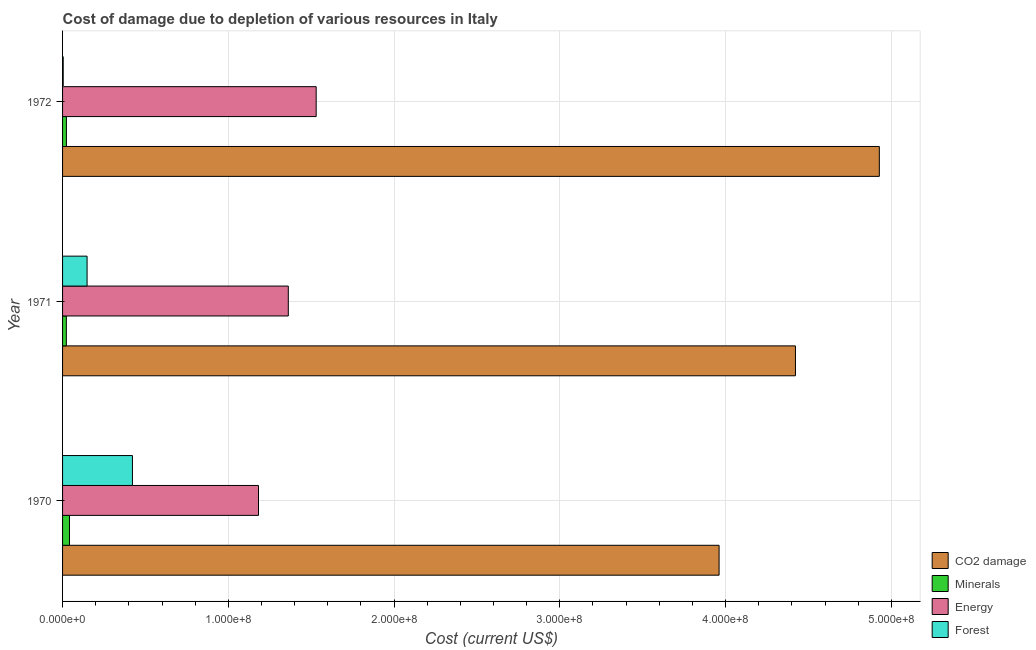How many different coloured bars are there?
Offer a terse response. 4. Are the number of bars per tick equal to the number of legend labels?
Your answer should be very brief. Yes. How many bars are there on the 3rd tick from the top?
Ensure brevity in your answer.  4. How many bars are there on the 2nd tick from the bottom?
Your answer should be very brief. 4. What is the label of the 2nd group of bars from the top?
Your answer should be compact. 1971. In how many cases, is the number of bars for a given year not equal to the number of legend labels?
Provide a short and direct response. 0. What is the cost of damage due to depletion of coal in 1971?
Provide a succinct answer. 4.42e+08. Across all years, what is the maximum cost of damage due to depletion of energy?
Make the answer very short. 1.53e+08. Across all years, what is the minimum cost of damage due to depletion of minerals?
Provide a succinct answer. 2.28e+06. In which year was the cost of damage due to depletion of coal minimum?
Ensure brevity in your answer.  1970. What is the total cost of damage due to depletion of energy in the graph?
Offer a very short reply. 4.07e+08. What is the difference between the cost of damage due to depletion of energy in 1970 and that in 1972?
Keep it short and to the point. -3.48e+07. What is the difference between the cost of damage due to depletion of energy in 1972 and the cost of damage due to depletion of minerals in 1971?
Your answer should be compact. 1.51e+08. What is the average cost of damage due to depletion of coal per year?
Keep it short and to the point. 4.44e+08. In the year 1971, what is the difference between the cost of damage due to depletion of forests and cost of damage due to depletion of coal?
Your response must be concise. -4.27e+08. Is the cost of damage due to depletion of coal in 1970 less than that in 1971?
Ensure brevity in your answer.  Yes. Is the difference between the cost of damage due to depletion of coal in 1970 and 1972 greater than the difference between the cost of damage due to depletion of energy in 1970 and 1972?
Give a very brief answer. No. What is the difference between the highest and the second highest cost of damage due to depletion of minerals?
Keep it short and to the point. 1.86e+06. What is the difference between the highest and the lowest cost of damage due to depletion of energy?
Offer a very short reply. 3.48e+07. In how many years, is the cost of damage due to depletion of coal greater than the average cost of damage due to depletion of coal taken over all years?
Offer a terse response. 1. Is the sum of the cost of damage due to depletion of forests in 1970 and 1971 greater than the maximum cost of damage due to depletion of coal across all years?
Offer a terse response. No. Is it the case that in every year, the sum of the cost of damage due to depletion of coal and cost of damage due to depletion of minerals is greater than the sum of cost of damage due to depletion of energy and cost of damage due to depletion of forests?
Your answer should be very brief. Yes. What does the 2nd bar from the top in 1970 represents?
Offer a terse response. Energy. What does the 2nd bar from the bottom in 1972 represents?
Keep it short and to the point. Minerals. Are all the bars in the graph horizontal?
Keep it short and to the point. Yes. How many years are there in the graph?
Your answer should be compact. 3. What is the difference between two consecutive major ticks on the X-axis?
Make the answer very short. 1.00e+08. Does the graph contain grids?
Give a very brief answer. Yes. Where does the legend appear in the graph?
Offer a very short reply. Bottom right. How are the legend labels stacked?
Your response must be concise. Vertical. What is the title of the graph?
Offer a very short reply. Cost of damage due to depletion of various resources in Italy . What is the label or title of the X-axis?
Your answer should be compact. Cost (current US$). What is the label or title of the Y-axis?
Provide a short and direct response. Year. What is the Cost (current US$) in CO2 damage in 1970?
Ensure brevity in your answer.  3.96e+08. What is the Cost (current US$) in Minerals in 1970?
Give a very brief answer. 4.17e+06. What is the Cost (current US$) in Energy in 1970?
Your response must be concise. 1.18e+08. What is the Cost (current US$) in Forest in 1970?
Your answer should be compact. 4.22e+07. What is the Cost (current US$) of CO2 damage in 1971?
Make the answer very short. 4.42e+08. What is the Cost (current US$) of Minerals in 1971?
Make the answer very short. 2.28e+06. What is the Cost (current US$) in Energy in 1971?
Provide a succinct answer. 1.36e+08. What is the Cost (current US$) in Forest in 1971?
Give a very brief answer. 1.48e+07. What is the Cost (current US$) of CO2 damage in 1972?
Provide a short and direct response. 4.93e+08. What is the Cost (current US$) in Minerals in 1972?
Give a very brief answer. 2.32e+06. What is the Cost (current US$) of Energy in 1972?
Ensure brevity in your answer.  1.53e+08. What is the Cost (current US$) of Forest in 1972?
Keep it short and to the point. 3.87e+05. Across all years, what is the maximum Cost (current US$) in CO2 damage?
Make the answer very short. 4.93e+08. Across all years, what is the maximum Cost (current US$) in Minerals?
Your response must be concise. 4.17e+06. Across all years, what is the maximum Cost (current US$) of Energy?
Provide a short and direct response. 1.53e+08. Across all years, what is the maximum Cost (current US$) of Forest?
Offer a very short reply. 4.22e+07. Across all years, what is the minimum Cost (current US$) in CO2 damage?
Make the answer very short. 3.96e+08. Across all years, what is the minimum Cost (current US$) of Minerals?
Your answer should be compact. 2.28e+06. Across all years, what is the minimum Cost (current US$) of Energy?
Make the answer very short. 1.18e+08. Across all years, what is the minimum Cost (current US$) in Forest?
Ensure brevity in your answer.  3.87e+05. What is the total Cost (current US$) of CO2 damage in the graph?
Offer a terse response. 1.33e+09. What is the total Cost (current US$) of Minerals in the graph?
Provide a succinct answer. 8.77e+06. What is the total Cost (current US$) in Energy in the graph?
Ensure brevity in your answer.  4.07e+08. What is the total Cost (current US$) in Forest in the graph?
Your response must be concise. 5.73e+07. What is the difference between the Cost (current US$) in CO2 damage in 1970 and that in 1971?
Your answer should be very brief. -4.61e+07. What is the difference between the Cost (current US$) in Minerals in 1970 and that in 1971?
Offer a terse response. 1.89e+06. What is the difference between the Cost (current US$) in Energy in 1970 and that in 1971?
Offer a very short reply. -1.80e+07. What is the difference between the Cost (current US$) in Forest in 1970 and that in 1971?
Ensure brevity in your answer.  2.74e+07. What is the difference between the Cost (current US$) in CO2 damage in 1970 and that in 1972?
Offer a very short reply. -9.67e+07. What is the difference between the Cost (current US$) of Minerals in 1970 and that in 1972?
Ensure brevity in your answer.  1.86e+06. What is the difference between the Cost (current US$) of Energy in 1970 and that in 1972?
Keep it short and to the point. -3.48e+07. What is the difference between the Cost (current US$) in Forest in 1970 and that in 1972?
Provide a succinct answer. 4.18e+07. What is the difference between the Cost (current US$) of CO2 damage in 1971 and that in 1972?
Offer a terse response. -5.06e+07. What is the difference between the Cost (current US$) of Minerals in 1971 and that in 1972?
Your answer should be compact. -3.72e+04. What is the difference between the Cost (current US$) in Energy in 1971 and that in 1972?
Keep it short and to the point. -1.68e+07. What is the difference between the Cost (current US$) of Forest in 1971 and that in 1972?
Ensure brevity in your answer.  1.44e+07. What is the difference between the Cost (current US$) of CO2 damage in 1970 and the Cost (current US$) of Minerals in 1971?
Provide a short and direct response. 3.94e+08. What is the difference between the Cost (current US$) of CO2 damage in 1970 and the Cost (current US$) of Energy in 1971?
Your answer should be compact. 2.60e+08. What is the difference between the Cost (current US$) in CO2 damage in 1970 and the Cost (current US$) in Forest in 1971?
Keep it short and to the point. 3.81e+08. What is the difference between the Cost (current US$) in Minerals in 1970 and the Cost (current US$) in Energy in 1971?
Give a very brief answer. -1.32e+08. What is the difference between the Cost (current US$) in Minerals in 1970 and the Cost (current US$) in Forest in 1971?
Keep it short and to the point. -1.06e+07. What is the difference between the Cost (current US$) of Energy in 1970 and the Cost (current US$) of Forest in 1971?
Keep it short and to the point. 1.03e+08. What is the difference between the Cost (current US$) in CO2 damage in 1970 and the Cost (current US$) in Minerals in 1972?
Your answer should be compact. 3.94e+08. What is the difference between the Cost (current US$) of CO2 damage in 1970 and the Cost (current US$) of Energy in 1972?
Your response must be concise. 2.43e+08. What is the difference between the Cost (current US$) of CO2 damage in 1970 and the Cost (current US$) of Forest in 1972?
Keep it short and to the point. 3.96e+08. What is the difference between the Cost (current US$) in Minerals in 1970 and the Cost (current US$) in Energy in 1972?
Your response must be concise. -1.49e+08. What is the difference between the Cost (current US$) in Minerals in 1970 and the Cost (current US$) in Forest in 1972?
Provide a succinct answer. 3.79e+06. What is the difference between the Cost (current US$) in Energy in 1970 and the Cost (current US$) in Forest in 1972?
Offer a very short reply. 1.18e+08. What is the difference between the Cost (current US$) in CO2 damage in 1971 and the Cost (current US$) in Minerals in 1972?
Provide a succinct answer. 4.40e+08. What is the difference between the Cost (current US$) in CO2 damage in 1971 and the Cost (current US$) in Energy in 1972?
Provide a succinct answer. 2.89e+08. What is the difference between the Cost (current US$) of CO2 damage in 1971 and the Cost (current US$) of Forest in 1972?
Give a very brief answer. 4.42e+08. What is the difference between the Cost (current US$) in Minerals in 1971 and the Cost (current US$) in Energy in 1972?
Make the answer very short. -1.51e+08. What is the difference between the Cost (current US$) of Minerals in 1971 and the Cost (current US$) of Forest in 1972?
Offer a very short reply. 1.89e+06. What is the difference between the Cost (current US$) in Energy in 1971 and the Cost (current US$) in Forest in 1972?
Offer a terse response. 1.36e+08. What is the average Cost (current US$) of CO2 damage per year?
Ensure brevity in your answer.  4.44e+08. What is the average Cost (current US$) of Minerals per year?
Your answer should be very brief. 2.92e+06. What is the average Cost (current US$) of Energy per year?
Your answer should be compact. 1.36e+08. What is the average Cost (current US$) in Forest per year?
Your response must be concise. 1.91e+07. In the year 1970, what is the difference between the Cost (current US$) in CO2 damage and Cost (current US$) in Minerals?
Provide a short and direct response. 3.92e+08. In the year 1970, what is the difference between the Cost (current US$) in CO2 damage and Cost (current US$) in Energy?
Provide a short and direct response. 2.78e+08. In the year 1970, what is the difference between the Cost (current US$) of CO2 damage and Cost (current US$) of Forest?
Keep it short and to the point. 3.54e+08. In the year 1970, what is the difference between the Cost (current US$) of Minerals and Cost (current US$) of Energy?
Keep it short and to the point. -1.14e+08. In the year 1970, what is the difference between the Cost (current US$) of Minerals and Cost (current US$) of Forest?
Keep it short and to the point. -3.80e+07. In the year 1970, what is the difference between the Cost (current US$) in Energy and Cost (current US$) in Forest?
Offer a very short reply. 7.61e+07. In the year 1971, what is the difference between the Cost (current US$) in CO2 damage and Cost (current US$) in Minerals?
Give a very brief answer. 4.40e+08. In the year 1971, what is the difference between the Cost (current US$) in CO2 damage and Cost (current US$) in Energy?
Your answer should be very brief. 3.06e+08. In the year 1971, what is the difference between the Cost (current US$) in CO2 damage and Cost (current US$) in Forest?
Your response must be concise. 4.27e+08. In the year 1971, what is the difference between the Cost (current US$) in Minerals and Cost (current US$) in Energy?
Keep it short and to the point. -1.34e+08. In the year 1971, what is the difference between the Cost (current US$) of Minerals and Cost (current US$) of Forest?
Your response must be concise. -1.25e+07. In the year 1971, what is the difference between the Cost (current US$) in Energy and Cost (current US$) in Forest?
Keep it short and to the point. 1.21e+08. In the year 1972, what is the difference between the Cost (current US$) of CO2 damage and Cost (current US$) of Minerals?
Provide a short and direct response. 4.90e+08. In the year 1972, what is the difference between the Cost (current US$) of CO2 damage and Cost (current US$) of Energy?
Make the answer very short. 3.40e+08. In the year 1972, what is the difference between the Cost (current US$) of CO2 damage and Cost (current US$) of Forest?
Your answer should be compact. 4.92e+08. In the year 1972, what is the difference between the Cost (current US$) in Minerals and Cost (current US$) in Energy?
Provide a succinct answer. -1.51e+08. In the year 1972, what is the difference between the Cost (current US$) in Minerals and Cost (current US$) in Forest?
Your answer should be compact. 1.93e+06. In the year 1972, what is the difference between the Cost (current US$) in Energy and Cost (current US$) in Forest?
Keep it short and to the point. 1.53e+08. What is the ratio of the Cost (current US$) of CO2 damage in 1970 to that in 1971?
Ensure brevity in your answer.  0.9. What is the ratio of the Cost (current US$) in Minerals in 1970 to that in 1971?
Keep it short and to the point. 1.83. What is the ratio of the Cost (current US$) in Energy in 1970 to that in 1971?
Make the answer very short. 0.87. What is the ratio of the Cost (current US$) in Forest in 1970 to that in 1971?
Ensure brevity in your answer.  2.85. What is the ratio of the Cost (current US$) of CO2 damage in 1970 to that in 1972?
Make the answer very short. 0.8. What is the ratio of the Cost (current US$) of Minerals in 1970 to that in 1972?
Offer a terse response. 1.8. What is the ratio of the Cost (current US$) of Energy in 1970 to that in 1972?
Provide a short and direct response. 0.77. What is the ratio of the Cost (current US$) in Forest in 1970 to that in 1972?
Your answer should be very brief. 108.87. What is the ratio of the Cost (current US$) in CO2 damage in 1971 to that in 1972?
Offer a very short reply. 0.9. What is the ratio of the Cost (current US$) of Minerals in 1971 to that in 1972?
Make the answer very short. 0.98. What is the ratio of the Cost (current US$) in Energy in 1971 to that in 1972?
Offer a terse response. 0.89. What is the ratio of the Cost (current US$) in Forest in 1971 to that in 1972?
Make the answer very short. 38.2. What is the difference between the highest and the second highest Cost (current US$) in CO2 damage?
Provide a short and direct response. 5.06e+07. What is the difference between the highest and the second highest Cost (current US$) in Minerals?
Offer a terse response. 1.86e+06. What is the difference between the highest and the second highest Cost (current US$) in Energy?
Your response must be concise. 1.68e+07. What is the difference between the highest and the second highest Cost (current US$) in Forest?
Provide a short and direct response. 2.74e+07. What is the difference between the highest and the lowest Cost (current US$) in CO2 damage?
Your answer should be compact. 9.67e+07. What is the difference between the highest and the lowest Cost (current US$) in Minerals?
Keep it short and to the point. 1.89e+06. What is the difference between the highest and the lowest Cost (current US$) in Energy?
Your response must be concise. 3.48e+07. What is the difference between the highest and the lowest Cost (current US$) in Forest?
Keep it short and to the point. 4.18e+07. 